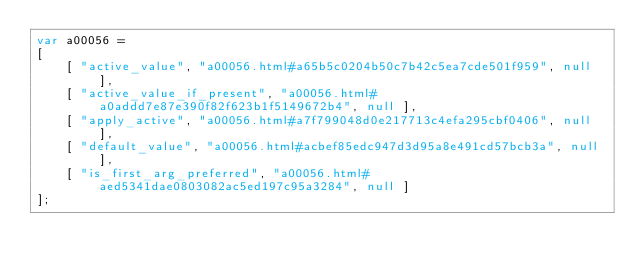<code> <loc_0><loc_0><loc_500><loc_500><_JavaScript_>var a00056 =
[
    [ "active_value", "a00056.html#a65b5c0204b50c7b42c5ea7cde501f959", null ],
    [ "active_value_if_present", "a00056.html#a0addd7e87e390f82f623b1f5149672b4", null ],
    [ "apply_active", "a00056.html#a7f799048d0e217713c4efa295cbf0406", null ],
    [ "default_value", "a00056.html#acbef85edc947d3d95a8e491cd57bcb3a", null ],
    [ "is_first_arg_preferred", "a00056.html#aed5341dae0803082ac5ed197c95a3284", null ]
];</code> 